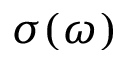<formula> <loc_0><loc_0><loc_500><loc_500>\sigma ( \omega )</formula> 